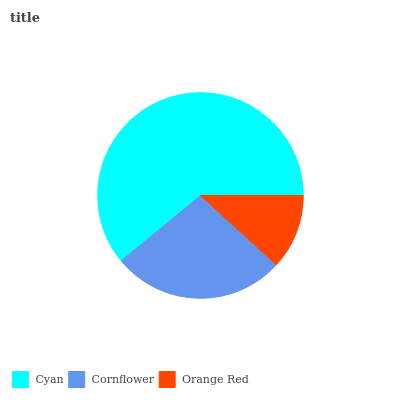Is Orange Red the minimum?
Answer yes or no. Yes. Is Cyan the maximum?
Answer yes or no. Yes. Is Cornflower the minimum?
Answer yes or no. No. Is Cornflower the maximum?
Answer yes or no. No. Is Cyan greater than Cornflower?
Answer yes or no. Yes. Is Cornflower less than Cyan?
Answer yes or no. Yes. Is Cornflower greater than Cyan?
Answer yes or no. No. Is Cyan less than Cornflower?
Answer yes or no. No. Is Cornflower the high median?
Answer yes or no. Yes. Is Cornflower the low median?
Answer yes or no. Yes. Is Orange Red the high median?
Answer yes or no. No. Is Cyan the low median?
Answer yes or no. No. 